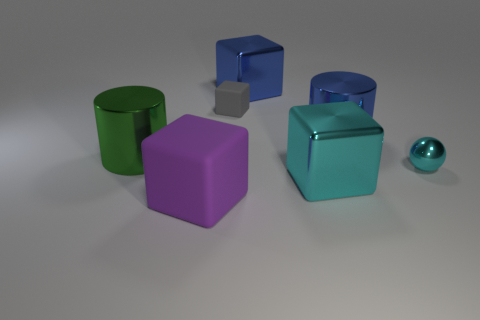Add 1 small red objects. How many objects exist? 8 Subtract all blocks. How many objects are left? 3 Add 7 metallic balls. How many metallic balls are left? 8 Add 4 small gray things. How many small gray things exist? 5 Subtract 1 cyan cubes. How many objects are left? 6 Subtract all large purple objects. Subtract all big objects. How many objects are left? 1 